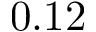Convert formula to latex. <formula><loc_0><loc_0><loc_500><loc_500>0 . 1 2</formula> 